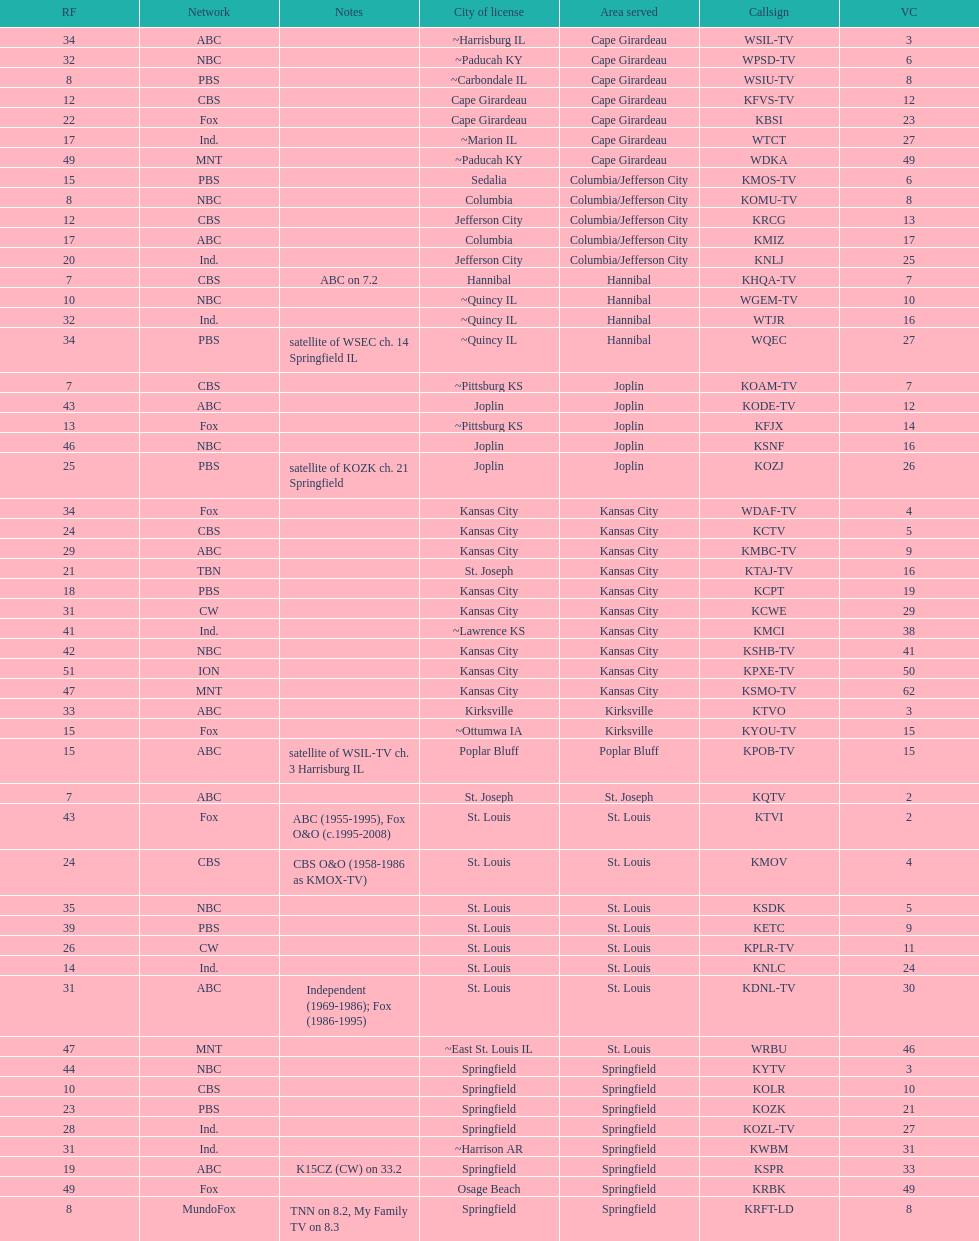How many television stations serve the cape girardeau area? 7. 